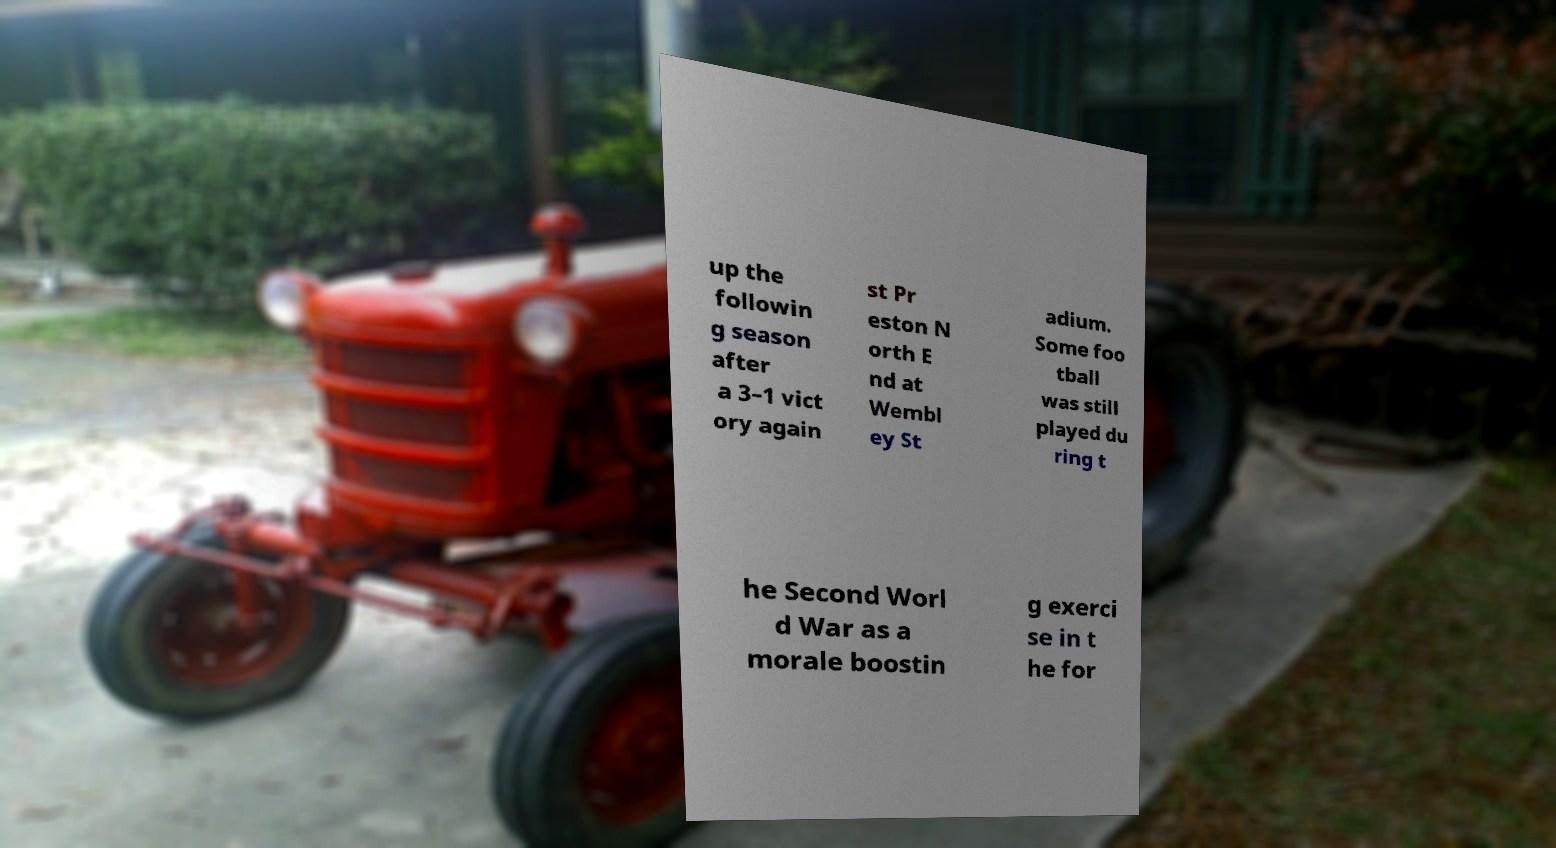Could you extract and type out the text from this image? up the followin g season after a 3–1 vict ory again st Pr eston N orth E nd at Wembl ey St adium. Some foo tball was still played du ring t he Second Worl d War as a morale boostin g exerci se in t he for 